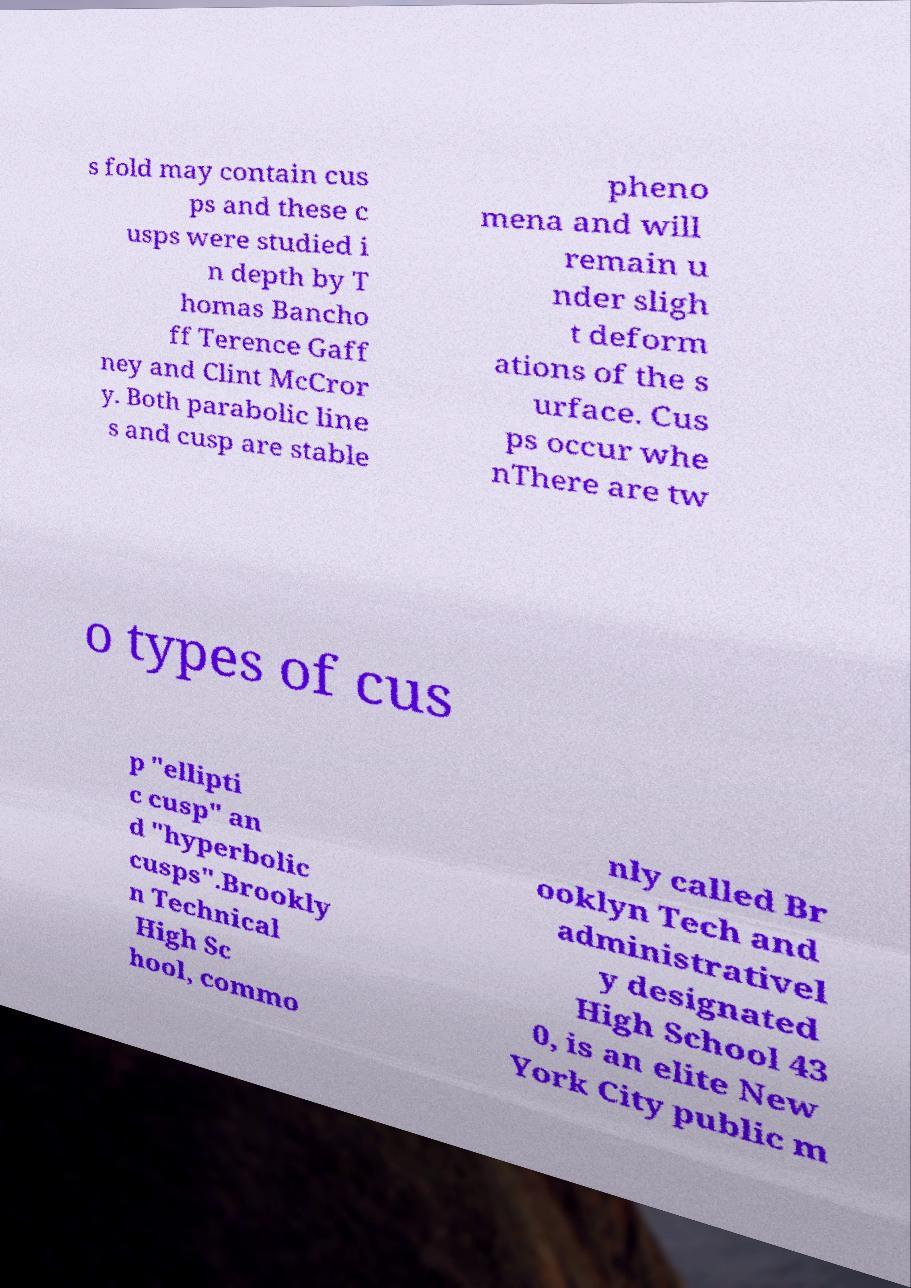Can you read and provide the text displayed in the image?This photo seems to have some interesting text. Can you extract and type it out for me? s fold may contain cus ps and these c usps were studied i n depth by T homas Bancho ff Terence Gaff ney and Clint McCror y. Both parabolic line s and cusp are stable pheno mena and will remain u nder sligh t deform ations of the s urface. Cus ps occur whe nThere are tw o types of cus p "ellipti c cusp" an d "hyperbolic cusps".Brookly n Technical High Sc hool, commo nly called Br ooklyn Tech and administrativel y designated High School 43 0, is an elite New York City public m 